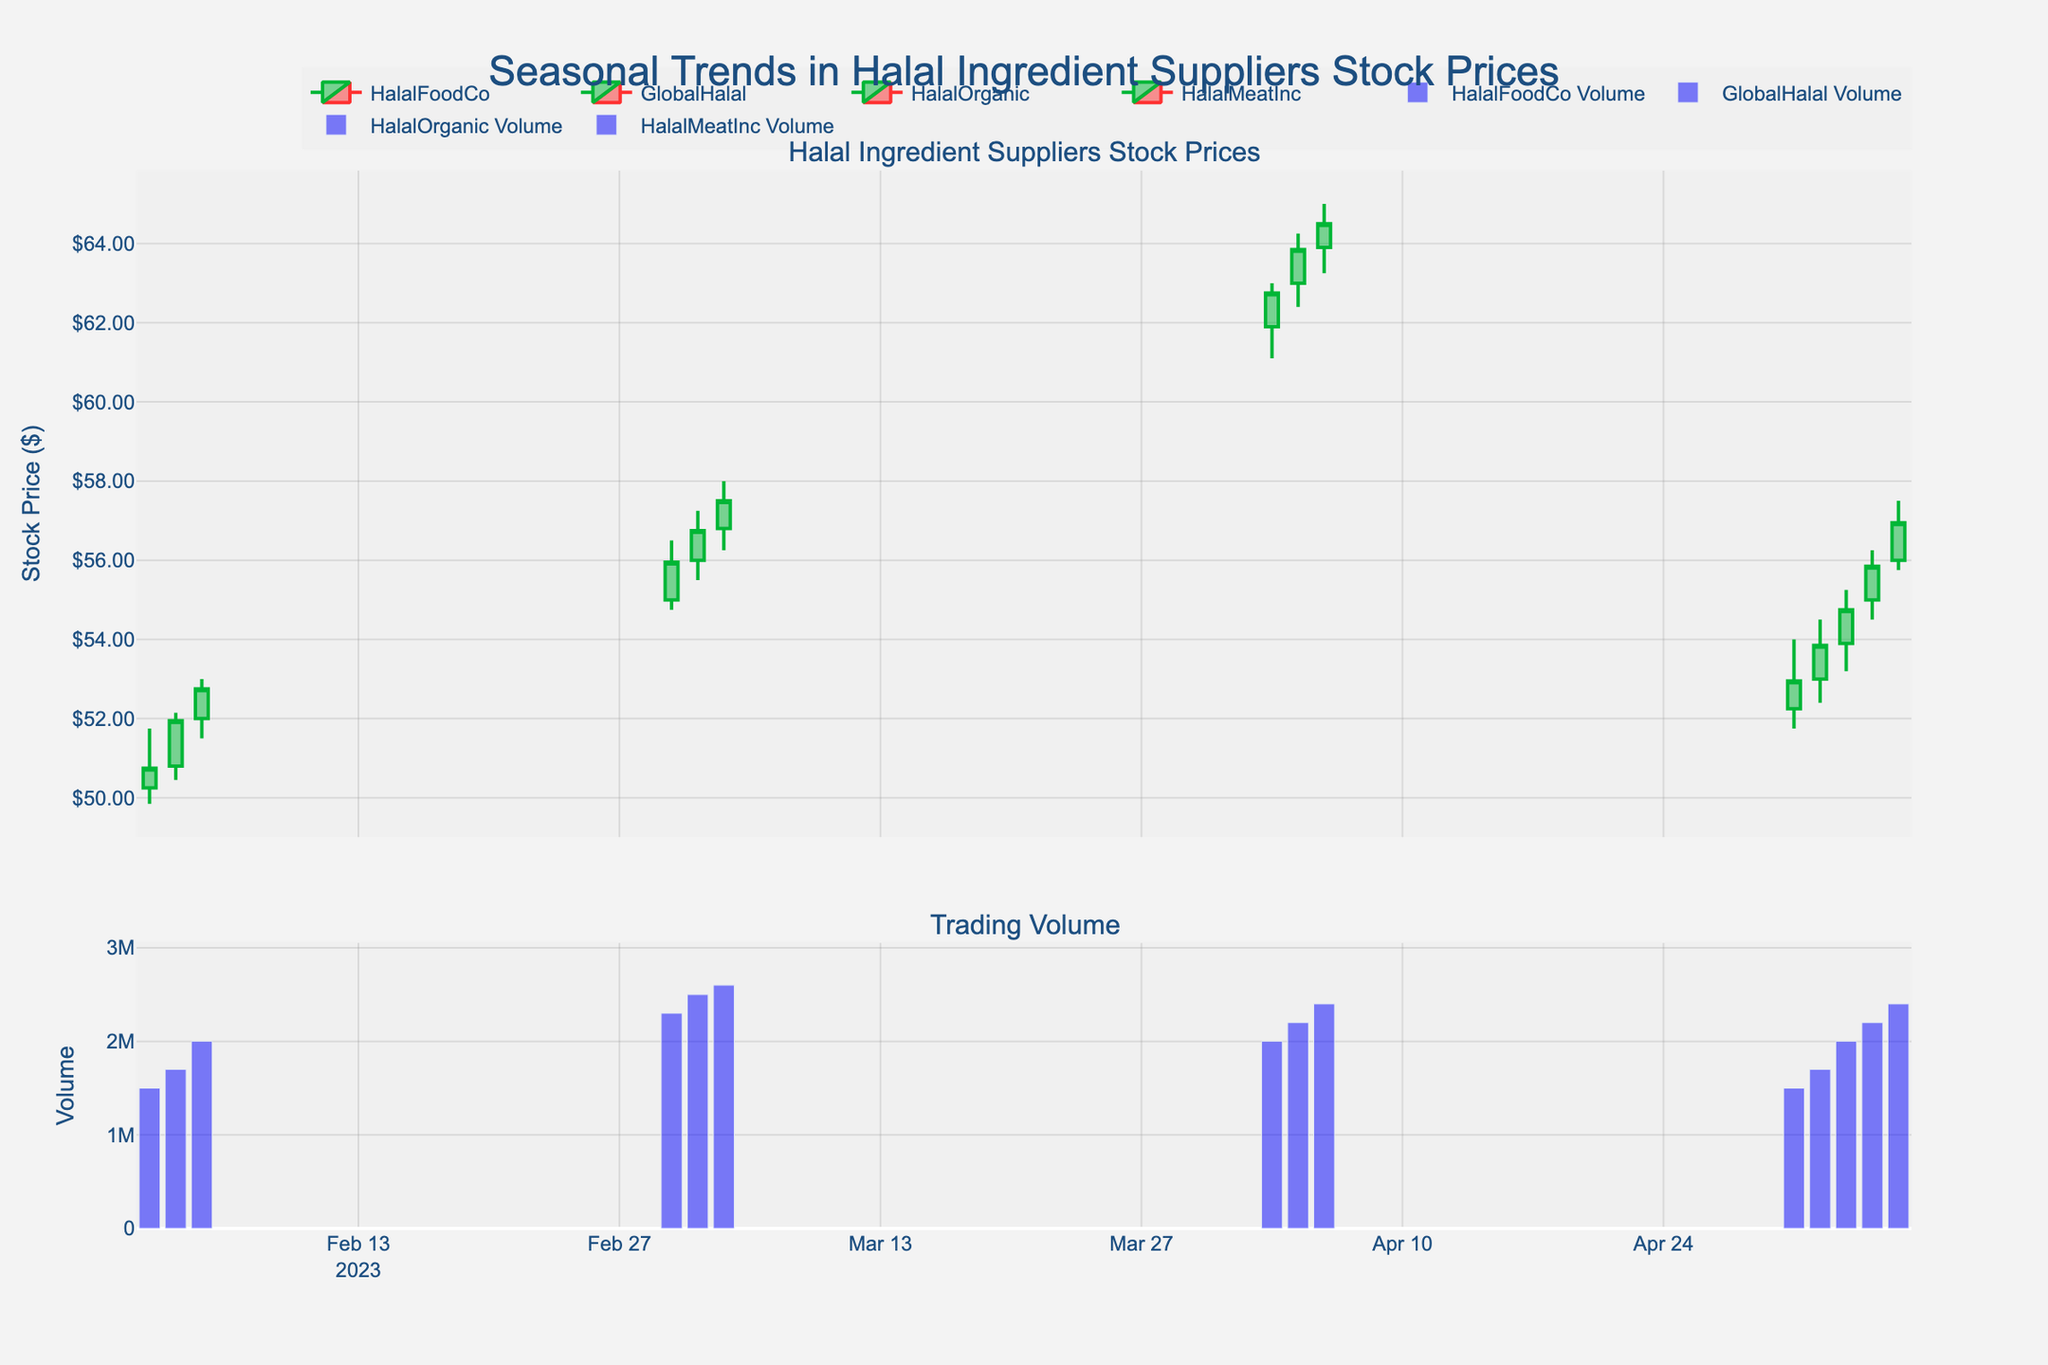What is the title of the figure? The title is typically placed at the top center of the figure. Reading it directly reveals that the title is 'Seasonal Trends in Halal Ingredient Suppliers Stock Prices'.
Answer: 'Seasonal Trends in Halal Ingredient Suppliers Stock Prices' What is the predominant color used for increasing stock prices? Observing the candlestick plot, the color for increasing stock prices (when the closing price is higher than the opening price) is green.
Answer: Green Which company has the highest trading volume recorded, and on which date? From the volume bar charts in the lower subplot, the highest trading volume can be identified as the tallest bar. By matching this bar with the company and date, we see it's GlobalHalal on 2023-03-05.
Answer: GlobalHalal on 2023-03-05 What's the trend in HalalMeatInc stock prices over the days listed? By observing the candlestick movements of HalalMeatInc, spanning from 2023-05-01 to 2023-05-05, the stock price shows an overall upward trend with higher highs and higher lows.
Answer: Upward trend Which month shows the highest average closing price for HalalFoodCo? Calculate the average closing price of HalalFoodCo in February (50.75 + 51.95 + 52.75 + 53.95 + 54.50 = 263.9/5 = 52.78). February has only HalalFoodCo's data, averaging 52.78. Compare it with HalalFoodCo's data in other months or the closest month to see if it remains highest.
Answer: February with an average closing price of 52.78 How many companies show stock prices in the subplot with candlestick charts? The legend at the top right of the figure lists the companies with their associated colors. Counting them will reveal three companies: HalalFoodCo, GlobalHalal, HalalOrganic, and HalalMeatInc.
Answer: Four companies During which dates did GlobalHalal show a consistent increase in stock price? Examine the candlestick pattern for GlobalHalal in March. Consistent increases occur on consecutive days when the closing price is higher than the previous day's close. The dates are from 2023-03-01 to 2023-03-05.
Answer: 2023-03-01 to 2023-03-05 Comparing HalalOrganic and HalalMeatInc, which company had a higher opening price trend in their respective months? Observe the opening prices for HalalOrganic in April (60.00, 61.00, 61.90, 63.00, 63.90) and HalalMeatInc in May (52.25, 53.00, 53.90, 55.00, 56.00). Calculate the average (HalalOrganic: 61.96 and HalalMeatInc: 54.03). Compare and conclude that HalalOrganic had the higher opening price trend.
Answer: HalalOrganic What's the total trading volume for HalalFoodCo over the listed days? Sum up the volume values for HalalFoodCo: 1500000 + 1700000 + 2000000 + 2200000 + 2400000 = 9800000. The total trading volume for HalalFoodCo is 9,800,000.
Answer: 9,800,000 